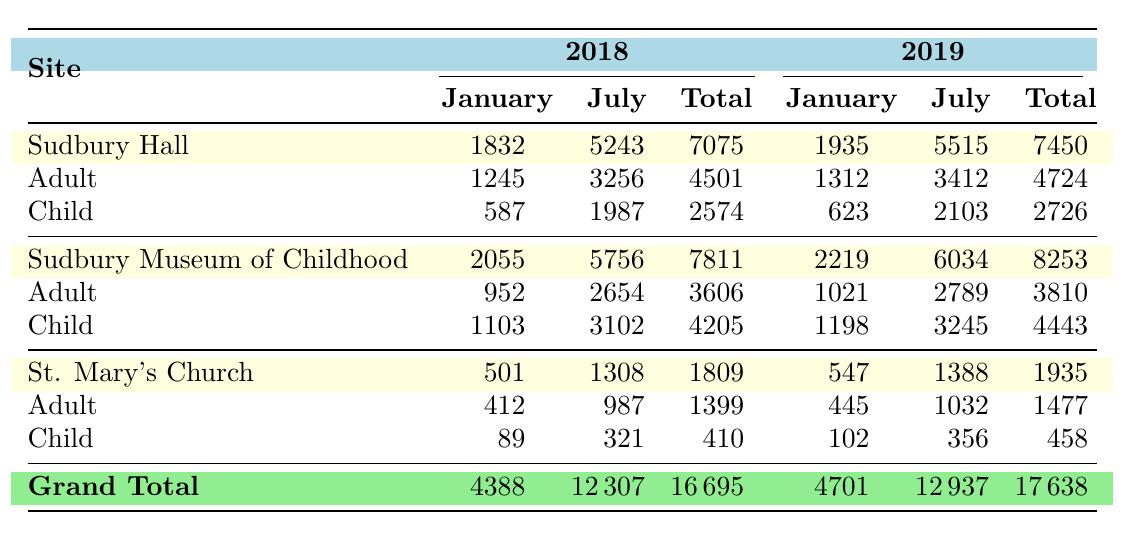What is the total number of visitors to Sudbury Hall in 2018? From the table, Under Sudbury Hall for the year 2018, the total visitors are given as 7075. This is already calculated by summing the adult and child visitors for January (1832) and July (5243). Therefore, the answer is 7075.
Answer: 7075 How many adult visitors did St. Mary's Church have in July 2019? In the table, under St. Mary's Church for July 2019, the adult visitors count is noted as 1032. This can be found directly in the row corresponding to St. Mary's Church and the year and month specified.
Answer: 1032 What is the average number of monthly visitors for the Sudbury Museum of Childhood in January across 2018 and 2019? To find the average monthly visitors for January at the Sudbury Museum of Childhood, first, we take the visitors from January 2018 (2055) and January 2019 (2219) and sum them: 2055 + 2219 = 4274. The average would then be this total divided by 2 (the number of years): 4274 / 2 = 2137.
Answer: 2137 Did St. Mary's Church have more visitors in January or July in 2018? The total visitors for St. Mary's Church in January 2018 is 1809 (from the table). In July 2018, the total is higher at 1308. Thus, comparing the two values, January has more visitors than July for that year.
Answer: Yes What is the total number of child visitors to all sites in July 2019? For July 2019, we refer to each site for child visitors: Sudbury Hall (2103), Sudbury Museum of Childhood (3245), and St. Mary's Church (356). Summing these gives: 2103 + 3245 + 356 = 5704. Therefore, the total number of child visitors in that month across all sites is 5704.
Answer: 5704 Comparing the grand totals, did visitor numbers increase from 2018 to 2019? The grand total of visitors for 2018 is 16695, while for 2019 it is 17638. To find out if there was an increase, we calculate the difference: 17638 - 16695 = 943. Since the difference is positive, we conclude that visitor numbers did indeed increase.
Answer: Yes What was the total visitor count in January 2018 across all sites? To find a total visitor count for January 2018 across all sites, we sum the totals: Sudbury Hall (1832), Sudbury Museum of Childhood (2055), and St. Mary's Church (501). Adding these together gives: 1832 + 2055 + 501 = 4388. Therefore, the total visitor count for January 2018 is 4388.
Answer: 4388 In which month did Sudbury Hall have its highest total visitors in 2019? Observing the total visitor counts for Sudbury Hall in 2019: January total is 1935, and July total is 5515. By comparing the two values, July has the highest total of 5515 visitors.
Answer: July 